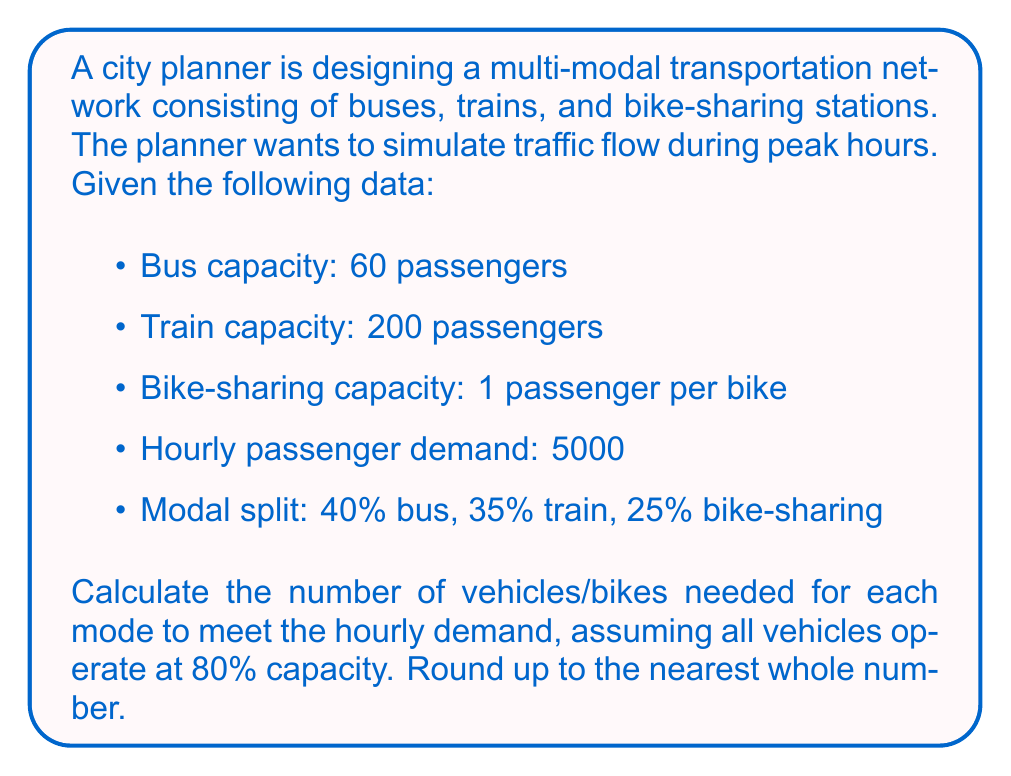Can you answer this question? Let's break this down step-by-step:

1. Calculate the number of passengers for each mode:
   - Bus: $5000 \times 0.40 = 2000$ passengers
   - Train: $5000 \times 0.35 = 1750$ passengers
   - Bike-sharing: $5000 \times 0.25 = 1250$ passengers

2. Calculate the effective capacity of each vehicle type at 80%:
   - Bus: $60 \times 0.80 = 48$ passengers per bus
   - Train: $200 \times 0.80 = 160$ passengers per train
   - Bike-sharing: $1 \times 0.80 = 0.8$ passengers per bike

3. Calculate the number of vehicles/bikes needed:
   - Buses: $\frac{2000}{48} = 41.67$, rounded up to 42 buses
   - Trains: $\frac{1750}{160} = 10.94$, rounded up to 11 trains
   - Bikes: $\frac{1250}{0.8} = 1562.5$, rounded up to 1563 bikes

Therefore, to meet the hourly demand during peak hours, the multi-modal transportation network needs:
- 42 buses
- 11 trains
- 1563 bikes
Answer: 42 buses, 11 trains, 1563 bikes 